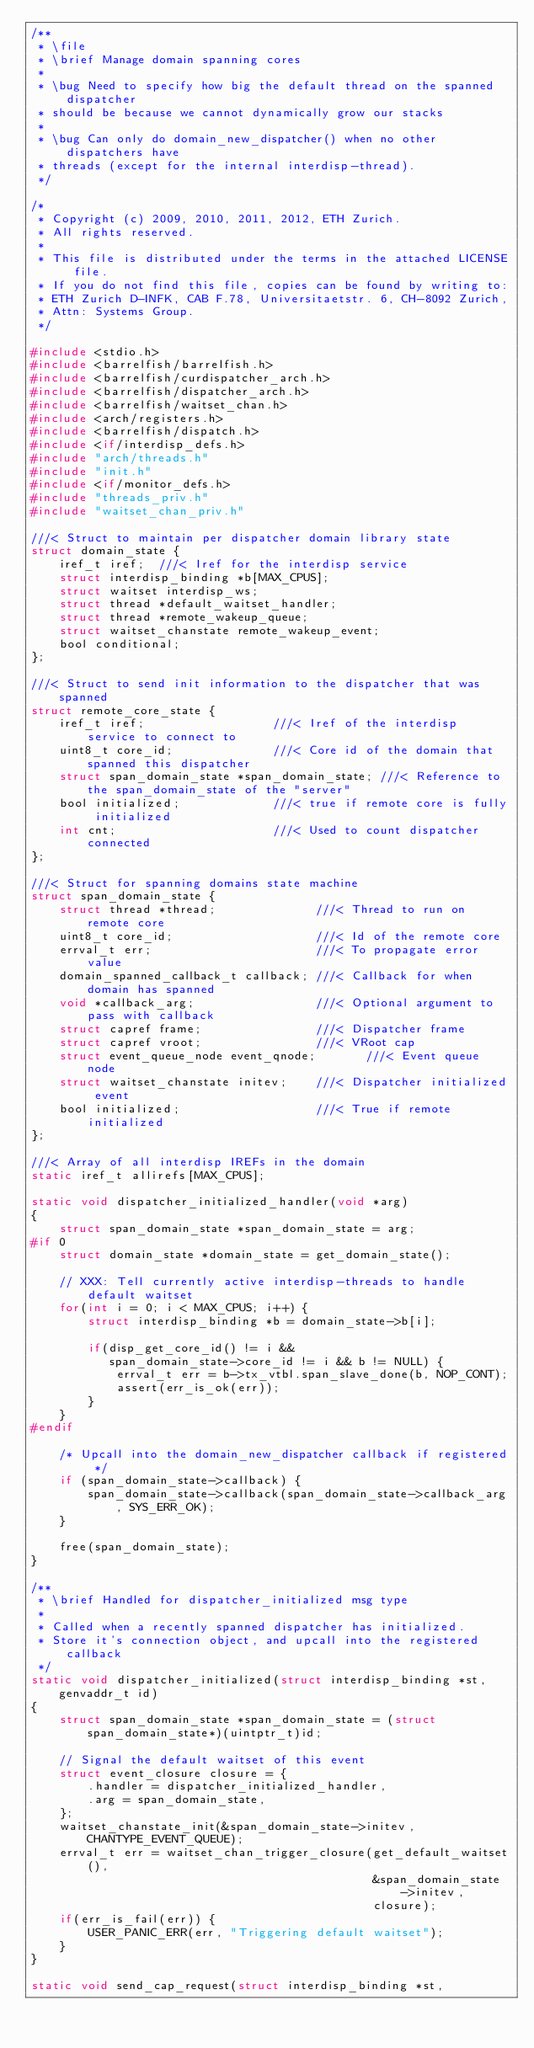Convert code to text. <code><loc_0><loc_0><loc_500><loc_500><_C_>/**
 * \file
 * \brief Manage domain spanning cores
 *
 * \bug Need to specify how big the default thread on the spanned dispatcher
 * should be because we cannot dynamically grow our stacks
 *
 * \bug Can only do domain_new_dispatcher() when no other dispatchers have
 * threads (except for the internal interdisp-thread).
 */

/*
 * Copyright (c) 2009, 2010, 2011, 2012, ETH Zurich.
 * All rights reserved.
 *
 * This file is distributed under the terms in the attached LICENSE file.
 * If you do not find this file, copies can be found by writing to:
 * ETH Zurich D-INFK, CAB F.78, Universitaetstr. 6, CH-8092 Zurich,
 * Attn: Systems Group.
 */

#include <stdio.h>
#include <barrelfish/barrelfish.h>
#include <barrelfish/curdispatcher_arch.h>
#include <barrelfish/dispatcher_arch.h>
#include <barrelfish/waitset_chan.h>
#include <arch/registers.h>
#include <barrelfish/dispatch.h>
#include <if/interdisp_defs.h>
#include "arch/threads.h"
#include "init.h"
#include <if/monitor_defs.h>
#include "threads_priv.h"
#include "waitset_chan_priv.h"

///< Struct to maintain per dispatcher domain library state
struct domain_state {
    iref_t iref;  ///< Iref for the interdisp service
    struct interdisp_binding *b[MAX_CPUS];
    struct waitset interdisp_ws;
    struct thread *default_waitset_handler;
    struct thread *remote_wakeup_queue;
    struct waitset_chanstate remote_wakeup_event;
    bool conditional;
};

///< Struct to send init information to the dispatcher that was spanned
struct remote_core_state {
    iref_t iref;                  ///< Iref of the interdisp service to connect to
    uint8_t core_id;              ///< Core id of the domain that spanned this dispatcher
    struct span_domain_state *span_domain_state; ///< Reference to the span_domain_state of the "server"
    bool initialized;             ///< true if remote core is fully initialized
    int cnt;                      ///< Used to count dispatcher connected
};

///< Struct for spanning domains state machine
struct span_domain_state {
    struct thread *thread;              ///< Thread to run on remote core
    uint8_t core_id;                    ///< Id of the remote core
    errval_t err;                       ///< To propagate error value
    domain_spanned_callback_t callback; ///< Callback for when domain has spanned
    void *callback_arg;                 ///< Optional argument to pass with callback
    struct capref frame;                ///< Dispatcher frame
    struct capref vroot;                ///< VRoot cap
    struct event_queue_node event_qnode;       ///< Event queue node
    struct waitset_chanstate initev;    ///< Dispatcher initialized event
    bool initialized;                   ///< True if remote initialized
};

///< Array of all interdisp IREFs in the domain
static iref_t allirefs[MAX_CPUS];

static void dispatcher_initialized_handler(void *arg)
{
    struct span_domain_state *span_domain_state = arg;
#if 0
    struct domain_state *domain_state = get_domain_state();

    // XXX: Tell currently active interdisp-threads to handle default waitset
    for(int i = 0; i < MAX_CPUS; i++) {
        struct interdisp_binding *b = domain_state->b[i];

        if(disp_get_core_id() != i &&
           span_domain_state->core_id != i && b != NULL) {
            errval_t err = b->tx_vtbl.span_slave_done(b, NOP_CONT);
            assert(err_is_ok(err));
        }
    }
#endif

    /* Upcall into the domain_new_dispatcher callback if registered */
    if (span_domain_state->callback) {
        span_domain_state->callback(span_domain_state->callback_arg, SYS_ERR_OK);
    }

    free(span_domain_state);
}

/**
 * \brief Handled for dispatcher_initialized msg type
 *
 * Called when a recently spanned dispatcher has initialized.
 * Store it's connection object, and upcall into the registered callback
 */
static void dispatcher_initialized(struct interdisp_binding *st, genvaddr_t id)
{
    struct span_domain_state *span_domain_state = (struct span_domain_state*)(uintptr_t)id;

    // Signal the default waitset of this event
    struct event_closure closure = {
        .handler = dispatcher_initialized_handler,
        .arg = span_domain_state,
    };
    waitset_chanstate_init(&span_domain_state->initev, CHANTYPE_EVENT_QUEUE);
    errval_t err = waitset_chan_trigger_closure(get_default_waitset(),
                                                &span_domain_state->initev,
                                                closure);
    if(err_is_fail(err)) {
        USER_PANIC_ERR(err, "Triggering default waitset");
    }
}

static void send_cap_request(struct interdisp_binding *st,</code> 